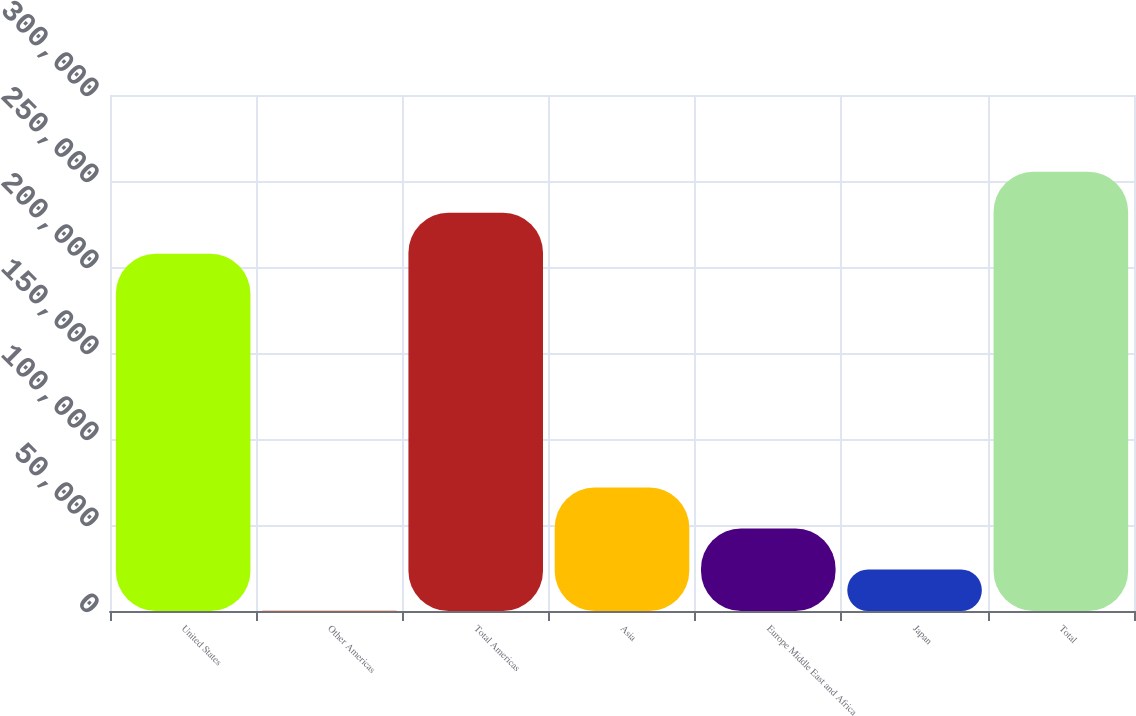<chart> <loc_0><loc_0><loc_500><loc_500><bar_chart><fcel>United States<fcel>Other Americas<fcel>Total Americas<fcel>Asia<fcel>Europe Middle East and Africa<fcel>Japan<fcel>Total<nl><fcel>207694<fcel>294<fcel>231536<fcel>71820.3<fcel>47978.2<fcel>24136.1<fcel>255378<nl></chart> 